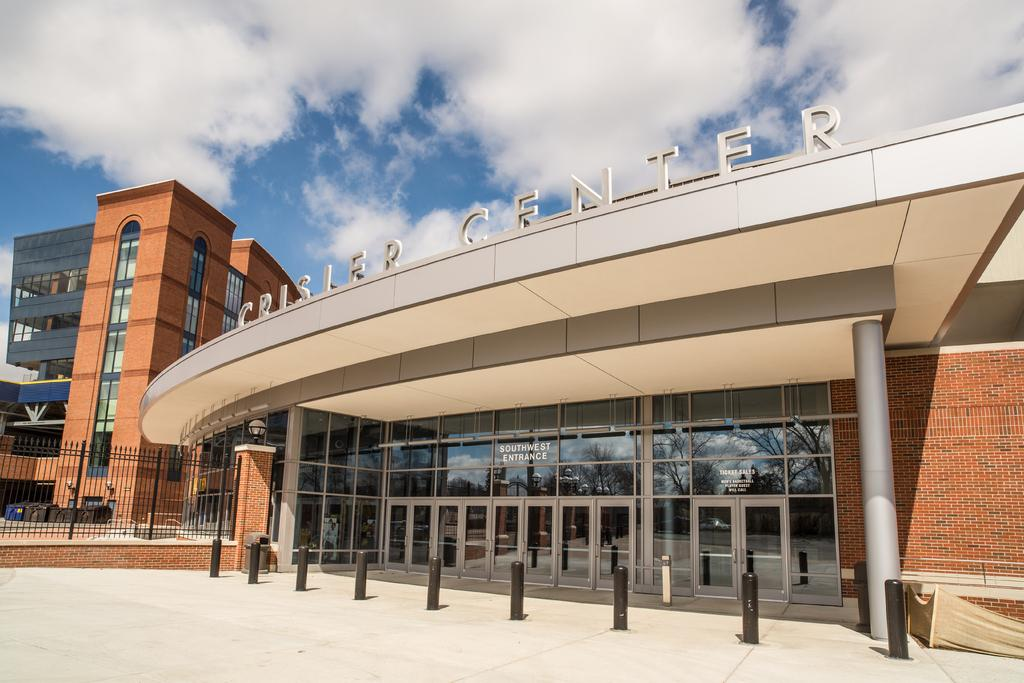What is the primary surface visible in the image? There is a floor in the image. What structures can be seen in the image? There are poles and a metal fence in the image. What can be seen in the distance in the image? There are buildings in the background of the image. What part of the natural environment is visible in the image? The sky is visible in the background of the image. How many tomatoes are hanging from the poles in the image? There are no tomatoes present in the image; the poles are not associated with any plants or fruits. 